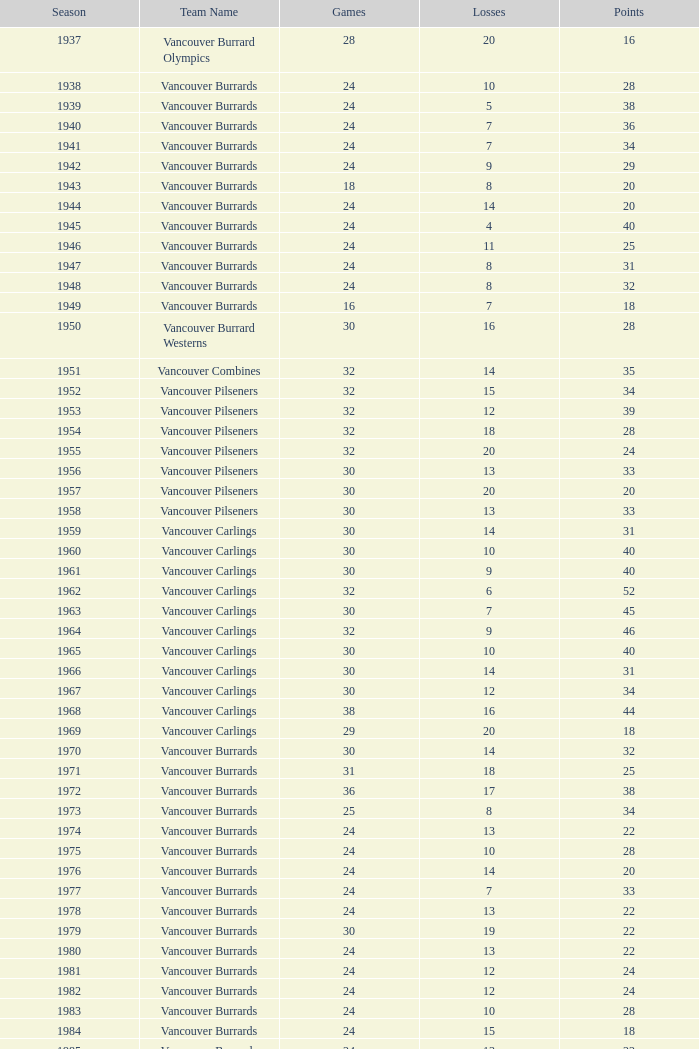What is the lowest point total for the vancouver burrards with under 8 losses and less than 24 games? 18.0. 